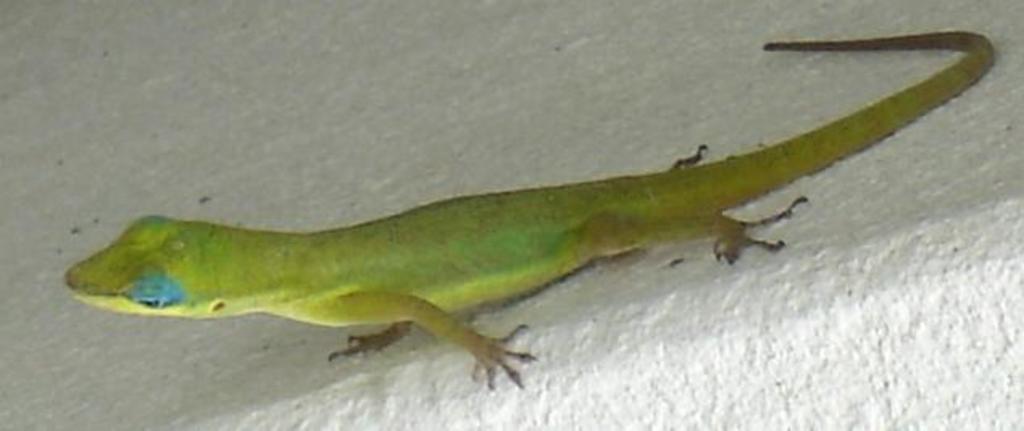Please provide a concise description of this image. In this image we can see a lizard on the surface. 